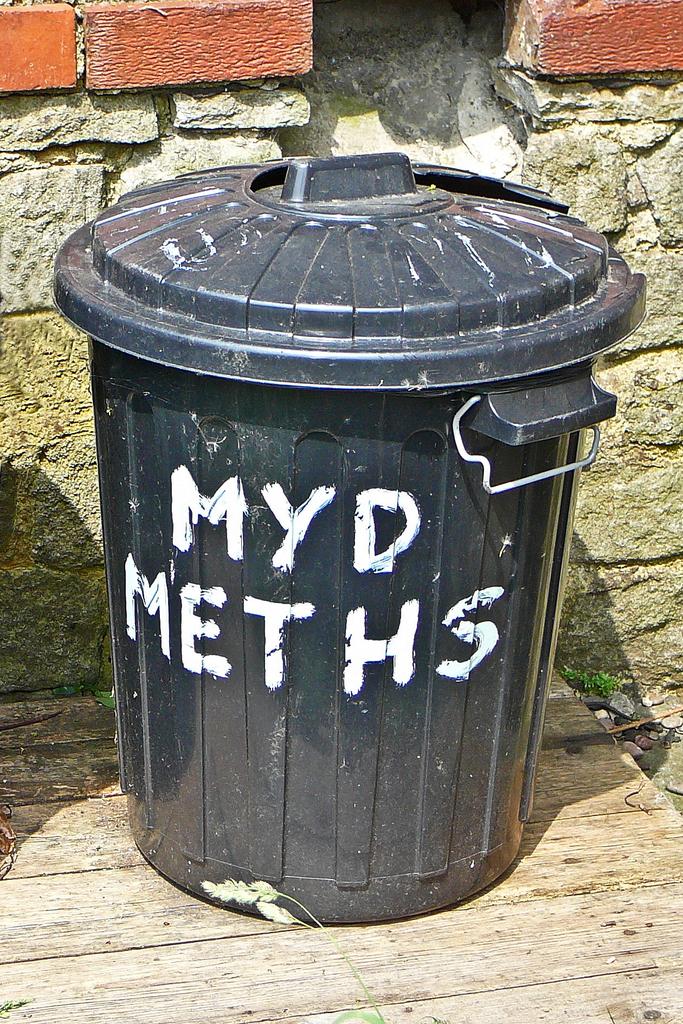What is written on this garbage can?
Keep it short and to the point. Myd meths. 